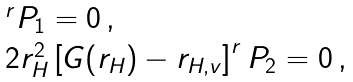Convert formula to latex. <formula><loc_0><loc_0><loc_500><loc_500>\begin{array} { l l } & ^ { r } P _ { 1 } = 0 \, , \\ & 2 r _ { H } ^ { 2 } \left [ G ( r _ { H } ) - r _ { H , v } \right ] ^ { r } P _ { 2 } = 0 \, , \end{array}</formula> 